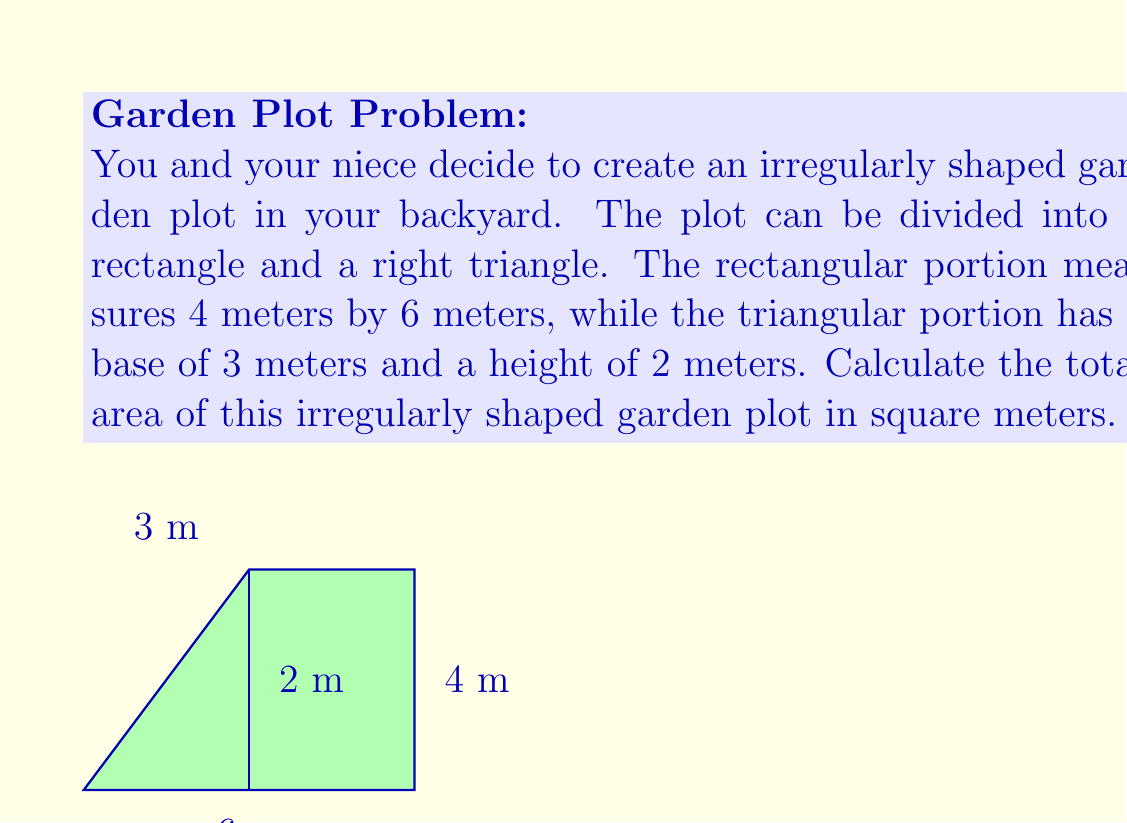Show me your answer to this math problem. To find the total area of the irregularly shaped garden plot, we need to calculate the areas of the rectangular portion and the triangular portion separately, then add them together.

1. Area of the rectangular portion:
   $$A_{rectangle} = length \times width = 6 \text{ m} \times 4 \text{ m} = 24 \text{ m}^2$$

2. Area of the triangular portion:
   $$A_{triangle} = \frac{1}{2} \times base \times height = \frac{1}{2} \times 3 \text{ m} \times 2 \text{ m} = 3 \text{ m}^2$$

3. Total area of the garden plot:
   $$A_{total} = A_{rectangle} + A_{triangle} = 24 \text{ m}^2 + 3 \text{ m}^2 = 27 \text{ m}^2$$

Therefore, the total area of the irregularly shaped garden plot is 27 square meters.
Answer: $27 \text{ m}^2$ 